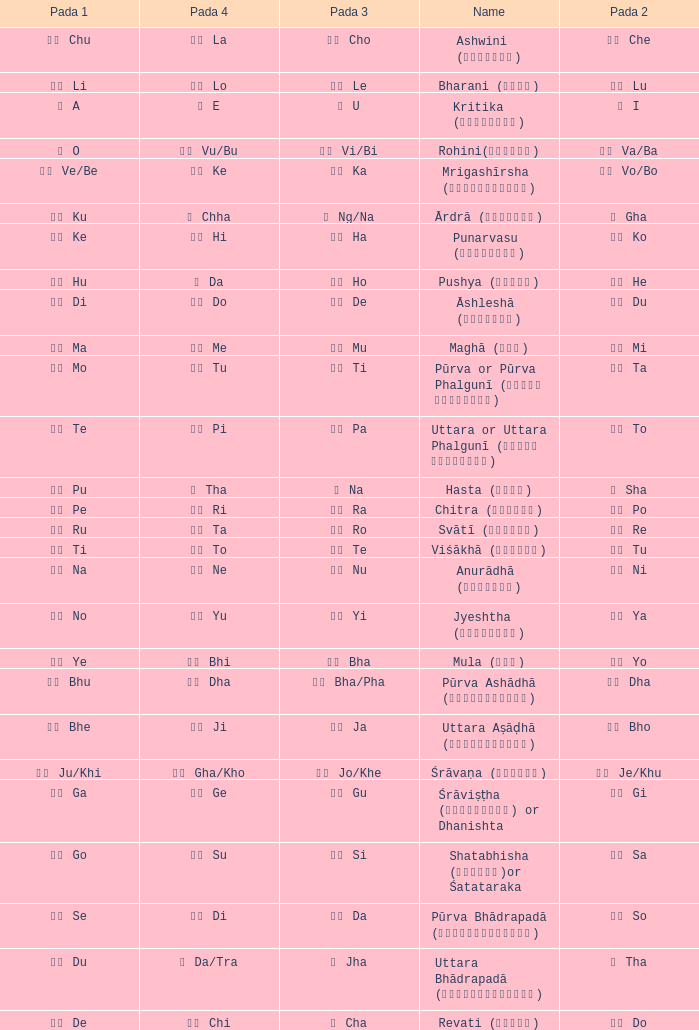What kind of Pada 4 has a Pada 1 of खी ju/khi? खो Gha/Kho. 